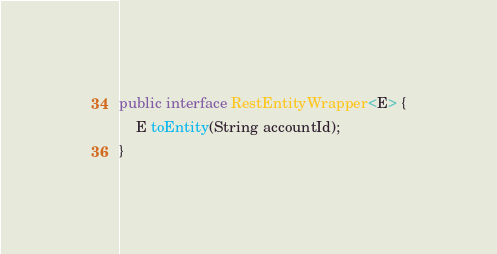<code> <loc_0><loc_0><loc_500><loc_500><_Java_>public interface RestEntityWrapper<E> {
    E toEntity(String accountId);
}
</code> 